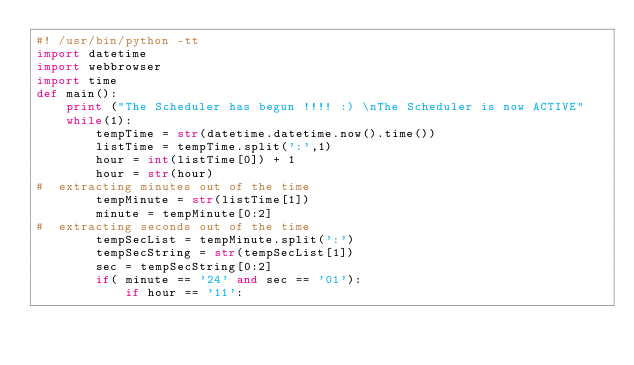<code> <loc_0><loc_0><loc_500><loc_500><_Python_>#! /usr/bin/python -tt
import datetime
import webbrowser
import time
def main():
    print ("The Scheduler has begun !!!! :) \nThe Scheduler is now ACTIVE"
    while(1):
        tempTime = str(datetime.datetime.now().time())
        listTime = tempTime.split(':',1)
        hour = int(listTime[0]) + 1
        hour = str(hour)
#  extracting minutes out of the time
        tempMinute = str(listTime[1])
        minute = tempMinute[0:2]
#  extracting seconds out of the time
        tempSecList = tempMinute.split(':')
        tempSecString = str(tempSecList[1])
        sec = tempSecString[0:2]
        if( minute == '24' and sec == '01'):
            if hour == '11':</code> 